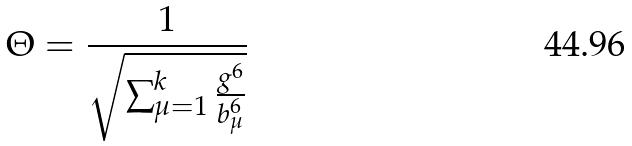<formula> <loc_0><loc_0><loc_500><loc_500>\Theta = \frac { 1 } { \sqrt { \sum _ { \mu = 1 } ^ { k } \frac { g ^ { 6 } } { b _ { \mu } ^ { 6 } } } }</formula> 